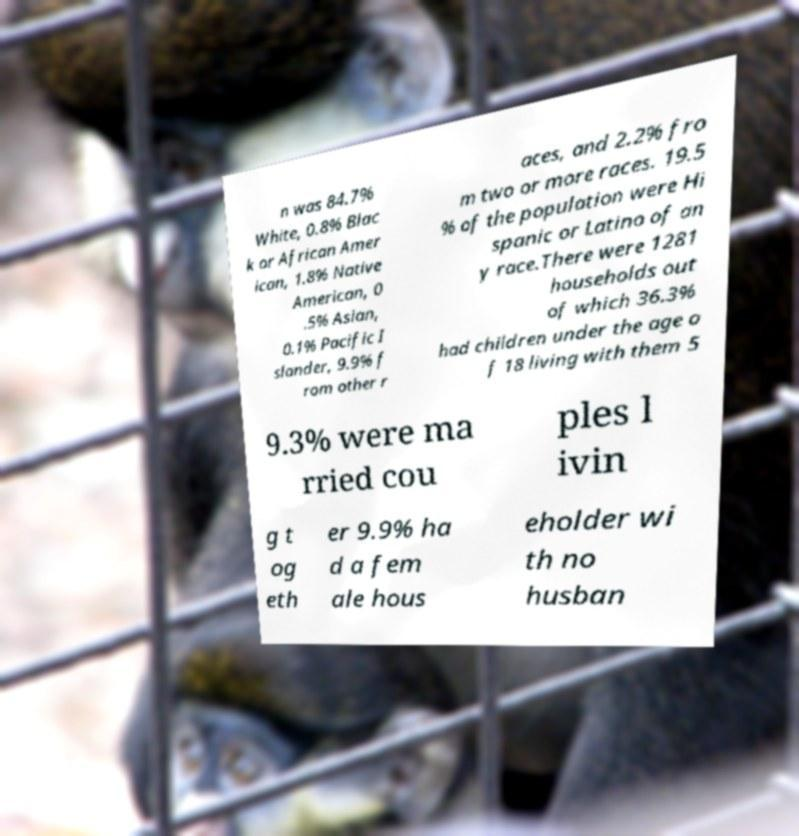Can you read and provide the text displayed in the image?This photo seems to have some interesting text. Can you extract and type it out for me? n was 84.7% White, 0.8% Blac k or African Amer ican, 1.8% Native American, 0 .5% Asian, 0.1% Pacific I slander, 9.9% f rom other r aces, and 2.2% fro m two or more races. 19.5 % of the population were Hi spanic or Latino of an y race.There were 1281 households out of which 36.3% had children under the age o f 18 living with them 5 9.3% were ma rried cou ples l ivin g t og eth er 9.9% ha d a fem ale hous eholder wi th no husban 